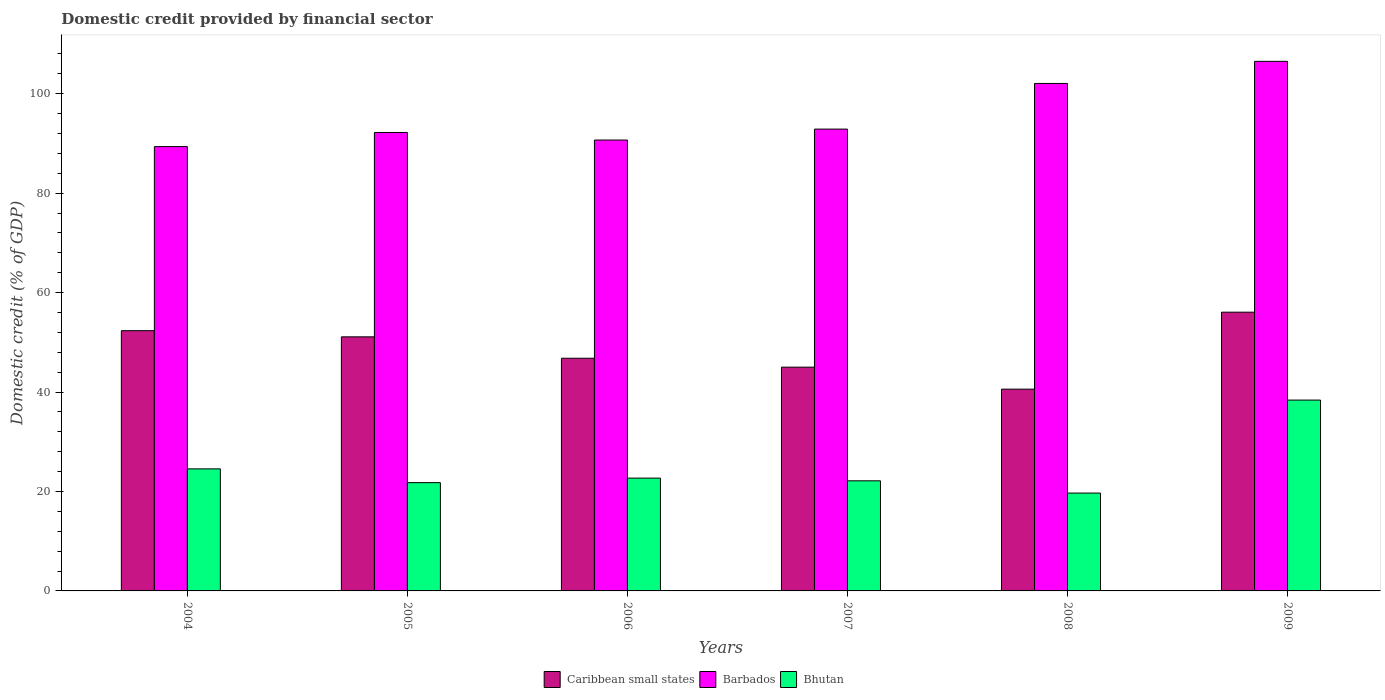Are the number of bars on each tick of the X-axis equal?
Make the answer very short. Yes. How many bars are there on the 6th tick from the left?
Provide a succinct answer. 3. How many bars are there on the 5th tick from the right?
Keep it short and to the point. 3. What is the label of the 4th group of bars from the left?
Keep it short and to the point. 2007. In how many cases, is the number of bars for a given year not equal to the number of legend labels?
Give a very brief answer. 0. What is the domestic credit in Barbados in 2005?
Make the answer very short. 92.21. Across all years, what is the maximum domestic credit in Caribbean small states?
Provide a succinct answer. 56.06. Across all years, what is the minimum domestic credit in Barbados?
Your answer should be very brief. 89.37. What is the total domestic credit in Bhutan in the graph?
Your response must be concise. 149.23. What is the difference between the domestic credit in Barbados in 2006 and that in 2007?
Make the answer very short. -2.2. What is the difference between the domestic credit in Barbados in 2008 and the domestic credit in Bhutan in 2009?
Ensure brevity in your answer.  63.69. What is the average domestic credit in Barbados per year?
Make the answer very short. 95.62. In the year 2008, what is the difference between the domestic credit in Caribbean small states and domestic credit in Barbados?
Provide a succinct answer. -61.49. In how many years, is the domestic credit in Bhutan greater than 20 %?
Offer a very short reply. 5. What is the ratio of the domestic credit in Caribbean small states in 2005 to that in 2009?
Give a very brief answer. 0.91. Is the domestic credit in Caribbean small states in 2004 less than that in 2005?
Your response must be concise. No. What is the difference between the highest and the second highest domestic credit in Caribbean small states?
Provide a succinct answer. 3.72. What is the difference between the highest and the lowest domestic credit in Bhutan?
Your answer should be compact. 18.7. What does the 1st bar from the left in 2009 represents?
Make the answer very short. Caribbean small states. What does the 3rd bar from the right in 2009 represents?
Offer a terse response. Caribbean small states. Is it the case that in every year, the sum of the domestic credit in Barbados and domestic credit in Bhutan is greater than the domestic credit in Caribbean small states?
Offer a terse response. Yes. Are all the bars in the graph horizontal?
Provide a short and direct response. No. How many years are there in the graph?
Keep it short and to the point. 6. Does the graph contain any zero values?
Provide a succinct answer. No. Does the graph contain grids?
Offer a terse response. No. Where does the legend appear in the graph?
Provide a succinct answer. Bottom center. How are the legend labels stacked?
Give a very brief answer. Horizontal. What is the title of the graph?
Provide a short and direct response. Domestic credit provided by financial sector. Does "Argentina" appear as one of the legend labels in the graph?
Give a very brief answer. No. What is the label or title of the Y-axis?
Ensure brevity in your answer.  Domestic credit (% of GDP). What is the Domestic credit (% of GDP) of Caribbean small states in 2004?
Provide a succinct answer. 52.34. What is the Domestic credit (% of GDP) in Barbados in 2004?
Offer a very short reply. 89.37. What is the Domestic credit (% of GDP) in Bhutan in 2004?
Your answer should be compact. 24.55. What is the Domestic credit (% of GDP) in Caribbean small states in 2005?
Keep it short and to the point. 51.11. What is the Domestic credit (% of GDP) of Barbados in 2005?
Provide a short and direct response. 92.21. What is the Domestic credit (% of GDP) of Bhutan in 2005?
Offer a terse response. 21.78. What is the Domestic credit (% of GDP) in Caribbean small states in 2006?
Offer a very short reply. 46.8. What is the Domestic credit (% of GDP) of Barbados in 2006?
Provide a short and direct response. 90.69. What is the Domestic credit (% of GDP) in Bhutan in 2006?
Give a very brief answer. 22.69. What is the Domestic credit (% of GDP) in Caribbean small states in 2007?
Your response must be concise. 45.01. What is the Domestic credit (% of GDP) in Barbados in 2007?
Offer a terse response. 92.89. What is the Domestic credit (% of GDP) in Bhutan in 2007?
Provide a short and direct response. 22.15. What is the Domestic credit (% of GDP) in Caribbean small states in 2008?
Provide a succinct answer. 40.58. What is the Domestic credit (% of GDP) of Barbados in 2008?
Provide a succinct answer. 102.07. What is the Domestic credit (% of GDP) in Bhutan in 2008?
Your response must be concise. 19.68. What is the Domestic credit (% of GDP) of Caribbean small states in 2009?
Make the answer very short. 56.06. What is the Domestic credit (% of GDP) of Barbados in 2009?
Offer a terse response. 106.52. What is the Domestic credit (% of GDP) in Bhutan in 2009?
Your answer should be very brief. 38.38. Across all years, what is the maximum Domestic credit (% of GDP) of Caribbean small states?
Provide a short and direct response. 56.06. Across all years, what is the maximum Domestic credit (% of GDP) of Barbados?
Ensure brevity in your answer.  106.52. Across all years, what is the maximum Domestic credit (% of GDP) in Bhutan?
Make the answer very short. 38.38. Across all years, what is the minimum Domestic credit (% of GDP) of Caribbean small states?
Give a very brief answer. 40.58. Across all years, what is the minimum Domestic credit (% of GDP) in Barbados?
Ensure brevity in your answer.  89.37. Across all years, what is the minimum Domestic credit (% of GDP) in Bhutan?
Offer a terse response. 19.68. What is the total Domestic credit (% of GDP) in Caribbean small states in the graph?
Your answer should be compact. 291.91. What is the total Domestic credit (% of GDP) in Barbados in the graph?
Offer a very short reply. 573.75. What is the total Domestic credit (% of GDP) in Bhutan in the graph?
Provide a short and direct response. 149.23. What is the difference between the Domestic credit (% of GDP) of Caribbean small states in 2004 and that in 2005?
Your answer should be very brief. 1.24. What is the difference between the Domestic credit (% of GDP) in Barbados in 2004 and that in 2005?
Provide a short and direct response. -2.84. What is the difference between the Domestic credit (% of GDP) of Bhutan in 2004 and that in 2005?
Give a very brief answer. 2.77. What is the difference between the Domestic credit (% of GDP) of Caribbean small states in 2004 and that in 2006?
Provide a short and direct response. 5.54. What is the difference between the Domestic credit (% of GDP) in Barbados in 2004 and that in 2006?
Your answer should be very brief. -1.32. What is the difference between the Domestic credit (% of GDP) of Bhutan in 2004 and that in 2006?
Your answer should be compact. 1.86. What is the difference between the Domestic credit (% of GDP) of Caribbean small states in 2004 and that in 2007?
Offer a terse response. 7.34. What is the difference between the Domestic credit (% of GDP) in Barbados in 2004 and that in 2007?
Make the answer very short. -3.52. What is the difference between the Domestic credit (% of GDP) of Bhutan in 2004 and that in 2007?
Provide a short and direct response. 2.4. What is the difference between the Domestic credit (% of GDP) of Caribbean small states in 2004 and that in 2008?
Your response must be concise. 11.76. What is the difference between the Domestic credit (% of GDP) of Barbados in 2004 and that in 2008?
Make the answer very short. -12.7. What is the difference between the Domestic credit (% of GDP) in Bhutan in 2004 and that in 2008?
Offer a terse response. 4.87. What is the difference between the Domestic credit (% of GDP) of Caribbean small states in 2004 and that in 2009?
Ensure brevity in your answer.  -3.72. What is the difference between the Domestic credit (% of GDP) in Barbados in 2004 and that in 2009?
Keep it short and to the point. -17.15. What is the difference between the Domestic credit (% of GDP) of Bhutan in 2004 and that in 2009?
Offer a very short reply. -13.84. What is the difference between the Domestic credit (% of GDP) of Caribbean small states in 2005 and that in 2006?
Give a very brief answer. 4.31. What is the difference between the Domestic credit (% of GDP) in Barbados in 2005 and that in 2006?
Your answer should be very brief. 1.52. What is the difference between the Domestic credit (% of GDP) of Bhutan in 2005 and that in 2006?
Your response must be concise. -0.91. What is the difference between the Domestic credit (% of GDP) in Caribbean small states in 2005 and that in 2007?
Your response must be concise. 6.1. What is the difference between the Domestic credit (% of GDP) of Barbados in 2005 and that in 2007?
Ensure brevity in your answer.  -0.68. What is the difference between the Domestic credit (% of GDP) in Bhutan in 2005 and that in 2007?
Your answer should be compact. -0.37. What is the difference between the Domestic credit (% of GDP) of Caribbean small states in 2005 and that in 2008?
Give a very brief answer. 10.52. What is the difference between the Domestic credit (% of GDP) of Barbados in 2005 and that in 2008?
Offer a terse response. -9.86. What is the difference between the Domestic credit (% of GDP) of Bhutan in 2005 and that in 2008?
Ensure brevity in your answer.  2.1. What is the difference between the Domestic credit (% of GDP) of Caribbean small states in 2005 and that in 2009?
Keep it short and to the point. -4.96. What is the difference between the Domestic credit (% of GDP) of Barbados in 2005 and that in 2009?
Keep it short and to the point. -14.3. What is the difference between the Domestic credit (% of GDP) in Bhutan in 2005 and that in 2009?
Provide a short and direct response. -16.61. What is the difference between the Domestic credit (% of GDP) in Caribbean small states in 2006 and that in 2007?
Make the answer very short. 1.79. What is the difference between the Domestic credit (% of GDP) of Barbados in 2006 and that in 2007?
Give a very brief answer. -2.2. What is the difference between the Domestic credit (% of GDP) of Bhutan in 2006 and that in 2007?
Ensure brevity in your answer.  0.54. What is the difference between the Domestic credit (% of GDP) in Caribbean small states in 2006 and that in 2008?
Offer a terse response. 6.22. What is the difference between the Domestic credit (% of GDP) of Barbados in 2006 and that in 2008?
Provide a succinct answer. -11.38. What is the difference between the Domestic credit (% of GDP) of Bhutan in 2006 and that in 2008?
Your answer should be compact. 3.01. What is the difference between the Domestic credit (% of GDP) of Caribbean small states in 2006 and that in 2009?
Provide a short and direct response. -9.26. What is the difference between the Domestic credit (% of GDP) in Barbados in 2006 and that in 2009?
Your answer should be compact. -15.83. What is the difference between the Domestic credit (% of GDP) of Bhutan in 2006 and that in 2009?
Keep it short and to the point. -15.7. What is the difference between the Domestic credit (% of GDP) in Caribbean small states in 2007 and that in 2008?
Provide a short and direct response. 4.42. What is the difference between the Domestic credit (% of GDP) in Barbados in 2007 and that in 2008?
Your answer should be compact. -9.19. What is the difference between the Domestic credit (% of GDP) in Bhutan in 2007 and that in 2008?
Give a very brief answer. 2.47. What is the difference between the Domestic credit (% of GDP) of Caribbean small states in 2007 and that in 2009?
Offer a very short reply. -11.06. What is the difference between the Domestic credit (% of GDP) of Barbados in 2007 and that in 2009?
Your response must be concise. -13.63. What is the difference between the Domestic credit (% of GDP) of Bhutan in 2007 and that in 2009?
Ensure brevity in your answer.  -16.24. What is the difference between the Domestic credit (% of GDP) of Caribbean small states in 2008 and that in 2009?
Give a very brief answer. -15.48. What is the difference between the Domestic credit (% of GDP) in Barbados in 2008 and that in 2009?
Your answer should be very brief. -4.44. What is the difference between the Domestic credit (% of GDP) in Bhutan in 2008 and that in 2009?
Your response must be concise. -18.7. What is the difference between the Domestic credit (% of GDP) in Caribbean small states in 2004 and the Domestic credit (% of GDP) in Barbados in 2005?
Your answer should be very brief. -39.87. What is the difference between the Domestic credit (% of GDP) of Caribbean small states in 2004 and the Domestic credit (% of GDP) of Bhutan in 2005?
Your answer should be very brief. 30.57. What is the difference between the Domestic credit (% of GDP) in Barbados in 2004 and the Domestic credit (% of GDP) in Bhutan in 2005?
Ensure brevity in your answer.  67.59. What is the difference between the Domestic credit (% of GDP) in Caribbean small states in 2004 and the Domestic credit (% of GDP) in Barbados in 2006?
Your response must be concise. -38.35. What is the difference between the Domestic credit (% of GDP) in Caribbean small states in 2004 and the Domestic credit (% of GDP) in Bhutan in 2006?
Offer a very short reply. 29.66. What is the difference between the Domestic credit (% of GDP) of Barbados in 2004 and the Domestic credit (% of GDP) of Bhutan in 2006?
Provide a succinct answer. 66.68. What is the difference between the Domestic credit (% of GDP) in Caribbean small states in 2004 and the Domestic credit (% of GDP) in Barbados in 2007?
Provide a short and direct response. -40.54. What is the difference between the Domestic credit (% of GDP) of Caribbean small states in 2004 and the Domestic credit (% of GDP) of Bhutan in 2007?
Ensure brevity in your answer.  30.2. What is the difference between the Domestic credit (% of GDP) of Barbados in 2004 and the Domestic credit (% of GDP) of Bhutan in 2007?
Ensure brevity in your answer.  67.22. What is the difference between the Domestic credit (% of GDP) of Caribbean small states in 2004 and the Domestic credit (% of GDP) of Barbados in 2008?
Give a very brief answer. -49.73. What is the difference between the Domestic credit (% of GDP) of Caribbean small states in 2004 and the Domestic credit (% of GDP) of Bhutan in 2008?
Keep it short and to the point. 32.66. What is the difference between the Domestic credit (% of GDP) of Barbados in 2004 and the Domestic credit (% of GDP) of Bhutan in 2008?
Provide a succinct answer. 69.69. What is the difference between the Domestic credit (% of GDP) in Caribbean small states in 2004 and the Domestic credit (% of GDP) in Barbados in 2009?
Your response must be concise. -54.17. What is the difference between the Domestic credit (% of GDP) of Caribbean small states in 2004 and the Domestic credit (% of GDP) of Bhutan in 2009?
Keep it short and to the point. 13.96. What is the difference between the Domestic credit (% of GDP) in Barbados in 2004 and the Domestic credit (% of GDP) in Bhutan in 2009?
Make the answer very short. 50.98. What is the difference between the Domestic credit (% of GDP) of Caribbean small states in 2005 and the Domestic credit (% of GDP) of Barbados in 2006?
Give a very brief answer. -39.58. What is the difference between the Domestic credit (% of GDP) of Caribbean small states in 2005 and the Domestic credit (% of GDP) of Bhutan in 2006?
Offer a terse response. 28.42. What is the difference between the Domestic credit (% of GDP) in Barbados in 2005 and the Domestic credit (% of GDP) in Bhutan in 2006?
Your answer should be compact. 69.52. What is the difference between the Domestic credit (% of GDP) in Caribbean small states in 2005 and the Domestic credit (% of GDP) in Barbados in 2007?
Give a very brief answer. -41.78. What is the difference between the Domestic credit (% of GDP) in Caribbean small states in 2005 and the Domestic credit (% of GDP) in Bhutan in 2007?
Offer a terse response. 28.96. What is the difference between the Domestic credit (% of GDP) in Barbados in 2005 and the Domestic credit (% of GDP) in Bhutan in 2007?
Give a very brief answer. 70.07. What is the difference between the Domestic credit (% of GDP) in Caribbean small states in 2005 and the Domestic credit (% of GDP) in Barbados in 2008?
Your answer should be compact. -50.97. What is the difference between the Domestic credit (% of GDP) of Caribbean small states in 2005 and the Domestic credit (% of GDP) of Bhutan in 2008?
Provide a short and direct response. 31.43. What is the difference between the Domestic credit (% of GDP) of Barbados in 2005 and the Domestic credit (% of GDP) of Bhutan in 2008?
Give a very brief answer. 72.53. What is the difference between the Domestic credit (% of GDP) of Caribbean small states in 2005 and the Domestic credit (% of GDP) of Barbados in 2009?
Give a very brief answer. -55.41. What is the difference between the Domestic credit (% of GDP) of Caribbean small states in 2005 and the Domestic credit (% of GDP) of Bhutan in 2009?
Offer a terse response. 12.72. What is the difference between the Domestic credit (% of GDP) of Barbados in 2005 and the Domestic credit (% of GDP) of Bhutan in 2009?
Give a very brief answer. 53.83. What is the difference between the Domestic credit (% of GDP) of Caribbean small states in 2006 and the Domestic credit (% of GDP) of Barbados in 2007?
Offer a terse response. -46.09. What is the difference between the Domestic credit (% of GDP) in Caribbean small states in 2006 and the Domestic credit (% of GDP) in Bhutan in 2007?
Your response must be concise. 24.65. What is the difference between the Domestic credit (% of GDP) in Barbados in 2006 and the Domestic credit (% of GDP) in Bhutan in 2007?
Keep it short and to the point. 68.54. What is the difference between the Domestic credit (% of GDP) of Caribbean small states in 2006 and the Domestic credit (% of GDP) of Barbados in 2008?
Your answer should be compact. -55.27. What is the difference between the Domestic credit (% of GDP) in Caribbean small states in 2006 and the Domestic credit (% of GDP) in Bhutan in 2008?
Keep it short and to the point. 27.12. What is the difference between the Domestic credit (% of GDP) in Barbados in 2006 and the Domestic credit (% of GDP) in Bhutan in 2008?
Your answer should be compact. 71.01. What is the difference between the Domestic credit (% of GDP) of Caribbean small states in 2006 and the Domestic credit (% of GDP) of Barbados in 2009?
Keep it short and to the point. -59.71. What is the difference between the Domestic credit (% of GDP) in Caribbean small states in 2006 and the Domestic credit (% of GDP) in Bhutan in 2009?
Your answer should be very brief. 8.42. What is the difference between the Domestic credit (% of GDP) of Barbados in 2006 and the Domestic credit (% of GDP) of Bhutan in 2009?
Provide a succinct answer. 52.31. What is the difference between the Domestic credit (% of GDP) of Caribbean small states in 2007 and the Domestic credit (% of GDP) of Barbados in 2008?
Offer a terse response. -57.07. What is the difference between the Domestic credit (% of GDP) of Caribbean small states in 2007 and the Domestic credit (% of GDP) of Bhutan in 2008?
Your answer should be very brief. 25.33. What is the difference between the Domestic credit (% of GDP) of Barbados in 2007 and the Domestic credit (% of GDP) of Bhutan in 2008?
Ensure brevity in your answer.  73.21. What is the difference between the Domestic credit (% of GDP) in Caribbean small states in 2007 and the Domestic credit (% of GDP) in Barbados in 2009?
Keep it short and to the point. -61.51. What is the difference between the Domestic credit (% of GDP) of Caribbean small states in 2007 and the Domestic credit (% of GDP) of Bhutan in 2009?
Ensure brevity in your answer.  6.62. What is the difference between the Domestic credit (% of GDP) of Barbados in 2007 and the Domestic credit (% of GDP) of Bhutan in 2009?
Ensure brevity in your answer.  54.5. What is the difference between the Domestic credit (% of GDP) in Caribbean small states in 2008 and the Domestic credit (% of GDP) in Barbados in 2009?
Offer a terse response. -65.93. What is the difference between the Domestic credit (% of GDP) in Barbados in 2008 and the Domestic credit (% of GDP) in Bhutan in 2009?
Ensure brevity in your answer.  63.69. What is the average Domestic credit (% of GDP) in Caribbean small states per year?
Provide a short and direct response. 48.65. What is the average Domestic credit (% of GDP) of Barbados per year?
Make the answer very short. 95.62. What is the average Domestic credit (% of GDP) of Bhutan per year?
Your answer should be very brief. 24.87. In the year 2004, what is the difference between the Domestic credit (% of GDP) in Caribbean small states and Domestic credit (% of GDP) in Barbados?
Offer a terse response. -37.02. In the year 2004, what is the difference between the Domestic credit (% of GDP) of Caribbean small states and Domestic credit (% of GDP) of Bhutan?
Offer a terse response. 27.8. In the year 2004, what is the difference between the Domestic credit (% of GDP) of Barbados and Domestic credit (% of GDP) of Bhutan?
Make the answer very short. 64.82. In the year 2005, what is the difference between the Domestic credit (% of GDP) in Caribbean small states and Domestic credit (% of GDP) in Barbados?
Give a very brief answer. -41.1. In the year 2005, what is the difference between the Domestic credit (% of GDP) of Caribbean small states and Domestic credit (% of GDP) of Bhutan?
Give a very brief answer. 29.33. In the year 2005, what is the difference between the Domestic credit (% of GDP) in Barbados and Domestic credit (% of GDP) in Bhutan?
Keep it short and to the point. 70.43. In the year 2006, what is the difference between the Domestic credit (% of GDP) in Caribbean small states and Domestic credit (% of GDP) in Barbados?
Offer a terse response. -43.89. In the year 2006, what is the difference between the Domestic credit (% of GDP) in Caribbean small states and Domestic credit (% of GDP) in Bhutan?
Your response must be concise. 24.11. In the year 2006, what is the difference between the Domestic credit (% of GDP) in Barbados and Domestic credit (% of GDP) in Bhutan?
Make the answer very short. 68. In the year 2007, what is the difference between the Domestic credit (% of GDP) in Caribbean small states and Domestic credit (% of GDP) in Barbados?
Offer a very short reply. -47.88. In the year 2007, what is the difference between the Domestic credit (% of GDP) of Caribbean small states and Domestic credit (% of GDP) of Bhutan?
Give a very brief answer. 22.86. In the year 2007, what is the difference between the Domestic credit (% of GDP) of Barbados and Domestic credit (% of GDP) of Bhutan?
Offer a terse response. 70.74. In the year 2008, what is the difference between the Domestic credit (% of GDP) in Caribbean small states and Domestic credit (% of GDP) in Barbados?
Keep it short and to the point. -61.49. In the year 2008, what is the difference between the Domestic credit (% of GDP) in Caribbean small states and Domestic credit (% of GDP) in Bhutan?
Your response must be concise. 20.9. In the year 2008, what is the difference between the Domestic credit (% of GDP) of Barbados and Domestic credit (% of GDP) of Bhutan?
Offer a terse response. 82.39. In the year 2009, what is the difference between the Domestic credit (% of GDP) in Caribbean small states and Domestic credit (% of GDP) in Barbados?
Give a very brief answer. -50.45. In the year 2009, what is the difference between the Domestic credit (% of GDP) of Caribbean small states and Domestic credit (% of GDP) of Bhutan?
Ensure brevity in your answer.  17.68. In the year 2009, what is the difference between the Domestic credit (% of GDP) of Barbados and Domestic credit (% of GDP) of Bhutan?
Offer a terse response. 68.13. What is the ratio of the Domestic credit (% of GDP) of Caribbean small states in 2004 to that in 2005?
Provide a succinct answer. 1.02. What is the ratio of the Domestic credit (% of GDP) in Barbados in 2004 to that in 2005?
Your response must be concise. 0.97. What is the ratio of the Domestic credit (% of GDP) of Bhutan in 2004 to that in 2005?
Give a very brief answer. 1.13. What is the ratio of the Domestic credit (% of GDP) of Caribbean small states in 2004 to that in 2006?
Offer a very short reply. 1.12. What is the ratio of the Domestic credit (% of GDP) in Barbados in 2004 to that in 2006?
Provide a succinct answer. 0.99. What is the ratio of the Domestic credit (% of GDP) of Bhutan in 2004 to that in 2006?
Ensure brevity in your answer.  1.08. What is the ratio of the Domestic credit (% of GDP) of Caribbean small states in 2004 to that in 2007?
Make the answer very short. 1.16. What is the ratio of the Domestic credit (% of GDP) in Barbados in 2004 to that in 2007?
Your response must be concise. 0.96. What is the ratio of the Domestic credit (% of GDP) of Bhutan in 2004 to that in 2007?
Offer a very short reply. 1.11. What is the ratio of the Domestic credit (% of GDP) in Caribbean small states in 2004 to that in 2008?
Your answer should be compact. 1.29. What is the ratio of the Domestic credit (% of GDP) in Barbados in 2004 to that in 2008?
Your response must be concise. 0.88. What is the ratio of the Domestic credit (% of GDP) of Bhutan in 2004 to that in 2008?
Provide a short and direct response. 1.25. What is the ratio of the Domestic credit (% of GDP) of Caribbean small states in 2004 to that in 2009?
Keep it short and to the point. 0.93. What is the ratio of the Domestic credit (% of GDP) in Barbados in 2004 to that in 2009?
Keep it short and to the point. 0.84. What is the ratio of the Domestic credit (% of GDP) in Bhutan in 2004 to that in 2009?
Offer a terse response. 0.64. What is the ratio of the Domestic credit (% of GDP) in Caribbean small states in 2005 to that in 2006?
Provide a succinct answer. 1.09. What is the ratio of the Domestic credit (% of GDP) of Barbados in 2005 to that in 2006?
Keep it short and to the point. 1.02. What is the ratio of the Domestic credit (% of GDP) of Bhutan in 2005 to that in 2006?
Provide a succinct answer. 0.96. What is the ratio of the Domestic credit (% of GDP) of Caribbean small states in 2005 to that in 2007?
Provide a short and direct response. 1.14. What is the ratio of the Domestic credit (% of GDP) in Barbados in 2005 to that in 2007?
Make the answer very short. 0.99. What is the ratio of the Domestic credit (% of GDP) of Bhutan in 2005 to that in 2007?
Provide a succinct answer. 0.98. What is the ratio of the Domestic credit (% of GDP) in Caribbean small states in 2005 to that in 2008?
Keep it short and to the point. 1.26. What is the ratio of the Domestic credit (% of GDP) of Barbados in 2005 to that in 2008?
Offer a terse response. 0.9. What is the ratio of the Domestic credit (% of GDP) in Bhutan in 2005 to that in 2008?
Provide a succinct answer. 1.11. What is the ratio of the Domestic credit (% of GDP) in Caribbean small states in 2005 to that in 2009?
Keep it short and to the point. 0.91. What is the ratio of the Domestic credit (% of GDP) of Barbados in 2005 to that in 2009?
Ensure brevity in your answer.  0.87. What is the ratio of the Domestic credit (% of GDP) of Bhutan in 2005 to that in 2009?
Your answer should be compact. 0.57. What is the ratio of the Domestic credit (% of GDP) of Caribbean small states in 2006 to that in 2007?
Provide a succinct answer. 1.04. What is the ratio of the Domestic credit (% of GDP) of Barbados in 2006 to that in 2007?
Make the answer very short. 0.98. What is the ratio of the Domestic credit (% of GDP) in Bhutan in 2006 to that in 2007?
Provide a short and direct response. 1.02. What is the ratio of the Domestic credit (% of GDP) in Caribbean small states in 2006 to that in 2008?
Make the answer very short. 1.15. What is the ratio of the Domestic credit (% of GDP) of Barbados in 2006 to that in 2008?
Your answer should be compact. 0.89. What is the ratio of the Domestic credit (% of GDP) in Bhutan in 2006 to that in 2008?
Offer a very short reply. 1.15. What is the ratio of the Domestic credit (% of GDP) in Caribbean small states in 2006 to that in 2009?
Give a very brief answer. 0.83. What is the ratio of the Domestic credit (% of GDP) in Barbados in 2006 to that in 2009?
Provide a succinct answer. 0.85. What is the ratio of the Domestic credit (% of GDP) in Bhutan in 2006 to that in 2009?
Make the answer very short. 0.59. What is the ratio of the Domestic credit (% of GDP) of Caribbean small states in 2007 to that in 2008?
Make the answer very short. 1.11. What is the ratio of the Domestic credit (% of GDP) in Barbados in 2007 to that in 2008?
Offer a very short reply. 0.91. What is the ratio of the Domestic credit (% of GDP) of Bhutan in 2007 to that in 2008?
Make the answer very short. 1.13. What is the ratio of the Domestic credit (% of GDP) of Caribbean small states in 2007 to that in 2009?
Keep it short and to the point. 0.8. What is the ratio of the Domestic credit (% of GDP) of Barbados in 2007 to that in 2009?
Your answer should be compact. 0.87. What is the ratio of the Domestic credit (% of GDP) of Bhutan in 2007 to that in 2009?
Your answer should be very brief. 0.58. What is the ratio of the Domestic credit (% of GDP) of Caribbean small states in 2008 to that in 2009?
Ensure brevity in your answer.  0.72. What is the ratio of the Domestic credit (% of GDP) in Barbados in 2008 to that in 2009?
Keep it short and to the point. 0.96. What is the ratio of the Domestic credit (% of GDP) of Bhutan in 2008 to that in 2009?
Offer a very short reply. 0.51. What is the difference between the highest and the second highest Domestic credit (% of GDP) in Caribbean small states?
Give a very brief answer. 3.72. What is the difference between the highest and the second highest Domestic credit (% of GDP) of Barbados?
Provide a short and direct response. 4.44. What is the difference between the highest and the second highest Domestic credit (% of GDP) in Bhutan?
Ensure brevity in your answer.  13.84. What is the difference between the highest and the lowest Domestic credit (% of GDP) in Caribbean small states?
Your answer should be very brief. 15.48. What is the difference between the highest and the lowest Domestic credit (% of GDP) in Barbados?
Ensure brevity in your answer.  17.15. What is the difference between the highest and the lowest Domestic credit (% of GDP) in Bhutan?
Your answer should be very brief. 18.7. 